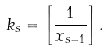Convert formula to latex. <formula><loc_0><loc_0><loc_500><loc_500>k _ { s } = \left [ \frac { 1 } { x _ { s - 1 } } \right ] .</formula> 